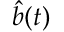<formula> <loc_0><loc_0><loc_500><loc_500>{ \hat { b } } ( t )</formula> 